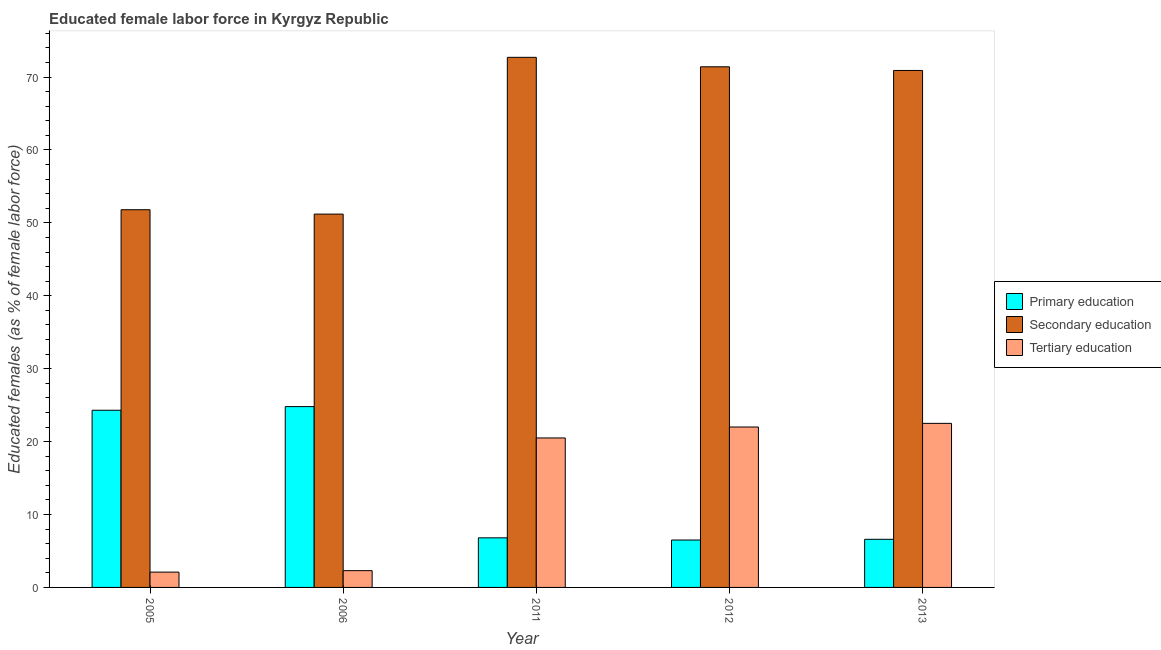What is the percentage of female labor force who received tertiary education in 2006?
Offer a terse response. 2.3. Across all years, what is the maximum percentage of female labor force who received tertiary education?
Give a very brief answer. 22.5. Across all years, what is the minimum percentage of female labor force who received tertiary education?
Offer a terse response. 2.1. In which year was the percentage of female labor force who received tertiary education maximum?
Make the answer very short. 2013. What is the total percentage of female labor force who received tertiary education in the graph?
Your answer should be compact. 69.4. What is the difference between the percentage of female labor force who received tertiary education in 2006 and that in 2012?
Provide a short and direct response. -19.7. What is the difference between the percentage of female labor force who received tertiary education in 2013 and the percentage of female labor force who received primary education in 2005?
Make the answer very short. 20.4. What is the average percentage of female labor force who received primary education per year?
Your response must be concise. 13.8. In the year 2011, what is the difference between the percentage of female labor force who received primary education and percentage of female labor force who received tertiary education?
Your answer should be very brief. 0. What is the ratio of the percentage of female labor force who received secondary education in 2005 to that in 2006?
Provide a short and direct response. 1.01. What is the difference between the highest and the second highest percentage of female labor force who received secondary education?
Offer a very short reply. 1.3. What is the difference between the highest and the lowest percentage of female labor force who received primary education?
Provide a short and direct response. 18.3. What does the 2nd bar from the left in 2013 represents?
Your answer should be very brief. Secondary education. What does the 1st bar from the right in 2013 represents?
Provide a short and direct response. Tertiary education. Are all the bars in the graph horizontal?
Keep it short and to the point. No. What is the difference between two consecutive major ticks on the Y-axis?
Make the answer very short. 10. Are the values on the major ticks of Y-axis written in scientific E-notation?
Provide a succinct answer. No. How many legend labels are there?
Make the answer very short. 3. How are the legend labels stacked?
Make the answer very short. Vertical. What is the title of the graph?
Offer a very short reply. Educated female labor force in Kyrgyz Republic. Does "Industrial Nitrous Oxide" appear as one of the legend labels in the graph?
Ensure brevity in your answer.  No. What is the label or title of the X-axis?
Offer a very short reply. Year. What is the label or title of the Y-axis?
Ensure brevity in your answer.  Educated females (as % of female labor force). What is the Educated females (as % of female labor force) in Primary education in 2005?
Your answer should be compact. 24.3. What is the Educated females (as % of female labor force) in Secondary education in 2005?
Keep it short and to the point. 51.8. What is the Educated females (as % of female labor force) in Tertiary education in 2005?
Offer a very short reply. 2.1. What is the Educated females (as % of female labor force) in Primary education in 2006?
Keep it short and to the point. 24.8. What is the Educated females (as % of female labor force) in Secondary education in 2006?
Provide a short and direct response. 51.2. What is the Educated females (as % of female labor force) in Tertiary education in 2006?
Your response must be concise. 2.3. What is the Educated females (as % of female labor force) of Primary education in 2011?
Keep it short and to the point. 6.8. What is the Educated females (as % of female labor force) of Secondary education in 2011?
Provide a short and direct response. 72.7. What is the Educated females (as % of female labor force) of Tertiary education in 2011?
Offer a terse response. 20.5. What is the Educated females (as % of female labor force) in Primary education in 2012?
Make the answer very short. 6.5. What is the Educated females (as % of female labor force) of Secondary education in 2012?
Your answer should be very brief. 71.4. What is the Educated females (as % of female labor force) of Tertiary education in 2012?
Keep it short and to the point. 22. What is the Educated females (as % of female labor force) of Primary education in 2013?
Provide a short and direct response. 6.6. What is the Educated females (as % of female labor force) in Secondary education in 2013?
Ensure brevity in your answer.  70.9. What is the Educated females (as % of female labor force) in Tertiary education in 2013?
Your response must be concise. 22.5. Across all years, what is the maximum Educated females (as % of female labor force) in Primary education?
Your answer should be very brief. 24.8. Across all years, what is the maximum Educated females (as % of female labor force) of Secondary education?
Your answer should be compact. 72.7. Across all years, what is the maximum Educated females (as % of female labor force) of Tertiary education?
Your answer should be compact. 22.5. Across all years, what is the minimum Educated females (as % of female labor force) in Primary education?
Provide a succinct answer. 6.5. Across all years, what is the minimum Educated females (as % of female labor force) of Secondary education?
Offer a very short reply. 51.2. Across all years, what is the minimum Educated females (as % of female labor force) of Tertiary education?
Your response must be concise. 2.1. What is the total Educated females (as % of female labor force) of Secondary education in the graph?
Keep it short and to the point. 318. What is the total Educated females (as % of female labor force) in Tertiary education in the graph?
Ensure brevity in your answer.  69.4. What is the difference between the Educated females (as % of female labor force) in Secondary education in 2005 and that in 2006?
Your response must be concise. 0.6. What is the difference between the Educated females (as % of female labor force) of Tertiary education in 2005 and that in 2006?
Keep it short and to the point. -0.2. What is the difference between the Educated females (as % of female labor force) in Secondary education in 2005 and that in 2011?
Your answer should be compact. -20.9. What is the difference between the Educated females (as % of female labor force) in Tertiary education in 2005 and that in 2011?
Offer a very short reply. -18.4. What is the difference between the Educated females (as % of female labor force) in Secondary education in 2005 and that in 2012?
Your response must be concise. -19.6. What is the difference between the Educated females (as % of female labor force) in Tertiary education in 2005 and that in 2012?
Offer a very short reply. -19.9. What is the difference between the Educated females (as % of female labor force) in Primary education in 2005 and that in 2013?
Ensure brevity in your answer.  17.7. What is the difference between the Educated females (as % of female labor force) of Secondary education in 2005 and that in 2013?
Make the answer very short. -19.1. What is the difference between the Educated females (as % of female labor force) in Tertiary education in 2005 and that in 2013?
Offer a very short reply. -20.4. What is the difference between the Educated females (as % of female labor force) in Secondary education in 2006 and that in 2011?
Make the answer very short. -21.5. What is the difference between the Educated females (as % of female labor force) of Tertiary education in 2006 and that in 2011?
Ensure brevity in your answer.  -18.2. What is the difference between the Educated females (as % of female labor force) of Primary education in 2006 and that in 2012?
Make the answer very short. 18.3. What is the difference between the Educated females (as % of female labor force) of Secondary education in 2006 and that in 2012?
Your response must be concise. -20.2. What is the difference between the Educated females (as % of female labor force) in Tertiary education in 2006 and that in 2012?
Provide a succinct answer. -19.7. What is the difference between the Educated females (as % of female labor force) in Primary education in 2006 and that in 2013?
Your response must be concise. 18.2. What is the difference between the Educated females (as % of female labor force) of Secondary education in 2006 and that in 2013?
Provide a succinct answer. -19.7. What is the difference between the Educated females (as % of female labor force) in Tertiary education in 2006 and that in 2013?
Your response must be concise. -20.2. What is the difference between the Educated females (as % of female labor force) in Secondary education in 2011 and that in 2012?
Keep it short and to the point. 1.3. What is the difference between the Educated females (as % of female labor force) in Primary education in 2011 and that in 2013?
Provide a short and direct response. 0.2. What is the difference between the Educated females (as % of female labor force) of Primary education in 2005 and the Educated females (as % of female labor force) of Secondary education in 2006?
Ensure brevity in your answer.  -26.9. What is the difference between the Educated females (as % of female labor force) of Primary education in 2005 and the Educated females (as % of female labor force) of Tertiary education in 2006?
Offer a terse response. 22. What is the difference between the Educated females (as % of female labor force) in Secondary education in 2005 and the Educated females (as % of female labor force) in Tertiary education in 2006?
Give a very brief answer. 49.5. What is the difference between the Educated females (as % of female labor force) in Primary education in 2005 and the Educated females (as % of female labor force) in Secondary education in 2011?
Make the answer very short. -48.4. What is the difference between the Educated females (as % of female labor force) in Primary education in 2005 and the Educated females (as % of female labor force) in Tertiary education in 2011?
Provide a short and direct response. 3.8. What is the difference between the Educated females (as % of female labor force) of Secondary education in 2005 and the Educated females (as % of female labor force) of Tertiary education in 2011?
Ensure brevity in your answer.  31.3. What is the difference between the Educated females (as % of female labor force) in Primary education in 2005 and the Educated females (as % of female labor force) in Secondary education in 2012?
Keep it short and to the point. -47.1. What is the difference between the Educated females (as % of female labor force) in Primary education in 2005 and the Educated females (as % of female labor force) in Tertiary education in 2012?
Give a very brief answer. 2.3. What is the difference between the Educated females (as % of female labor force) in Secondary education in 2005 and the Educated females (as % of female labor force) in Tertiary education in 2012?
Provide a short and direct response. 29.8. What is the difference between the Educated females (as % of female labor force) in Primary education in 2005 and the Educated females (as % of female labor force) in Secondary education in 2013?
Provide a short and direct response. -46.6. What is the difference between the Educated females (as % of female labor force) of Secondary education in 2005 and the Educated females (as % of female labor force) of Tertiary education in 2013?
Give a very brief answer. 29.3. What is the difference between the Educated females (as % of female labor force) in Primary education in 2006 and the Educated females (as % of female labor force) in Secondary education in 2011?
Keep it short and to the point. -47.9. What is the difference between the Educated females (as % of female labor force) of Secondary education in 2006 and the Educated females (as % of female labor force) of Tertiary education in 2011?
Your answer should be very brief. 30.7. What is the difference between the Educated females (as % of female labor force) of Primary education in 2006 and the Educated females (as % of female labor force) of Secondary education in 2012?
Your answer should be very brief. -46.6. What is the difference between the Educated females (as % of female labor force) in Secondary education in 2006 and the Educated females (as % of female labor force) in Tertiary education in 2012?
Give a very brief answer. 29.2. What is the difference between the Educated females (as % of female labor force) in Primary education in 2006 and the Educated females (as % of female labor force) in Secondary education in 2013?
Offer a very short reply. -46.1. What is the difference between the Educated females (as % of female labor force) of Primary education in 2006 and the Educated females (as % of female labor force) of Tertiary education in 2013?
Provide a short and direct response. 2.3. What is the difference between the Educated females (as % of female labor force) in Secondary education in 2006 and the Educated females (as % of female labor force) in Tertiary education in 2013?
Your answer should be very brief. 28.7. What is the difference between the Educated females (as % of female labor force) of Primary education in 2011 and the Educated females (as % of female labor force) of Secondary education in 2012?
Offer a terse response. -64.6. What is the difference between the Educated females (as % of female labor force) of Primary education in 2011 and the Educated females (as % of female labor force) of Tertiary education in 2012?
Make the answer very short. -15.2. What is the difference between the Educated females (as % of female labor force) in Secondary education in 2011 and the Educated females (as % of female labor force) in Tertiary education in 2012?
Ensure brevity in your answer.  50.7. What is the difference between the Educated females (as % of female labor force) of Primary education in 2011 and the Educated females (as % of female labor force) of Secondary education in 2013?
Make the answer very short. -64.1. What is the difference between the Educated females (as % of female labor force) of Primary education in 2011 and the Educated females (as % of female labor force) of Tertiary education in 2013?
Make the answer very short. -15.7. What is the difference between the Educated females (as % of female labor force) of Secondary education in 2011 and the Educated females (as % of female labor force) of Tertiary education in 2013?
Your answer should be compact. 50.2. What is the difference between the Educated females (as % of female labor force) of Primary education in 2012 and the Educated females (as % of female labor force) of Secondary education in 2013?
Ensure brevity in your answer.  -64.4. What is the difference between the Educated females (as % of female labor force) in Secondary education in 2012 and the Educated females (as % of female labor force) in Tertiary education in 2013?
Offer a terse response. 48.9. What is the average Educated females (as % of female labor force) in Primary education per year?
Offer a terse response. 13.8. What is the average Educated females (as % of female labor force) in Secondary education per year?
Your answer should be compact. 63.6. What is the average Educated females (as % of female labor force) of Tertiary education per year?
Offer a very short reply. 13.88. In the year 2005, what is the difference between the Educated females (as % of female labor force) in Primary education and Educated females (as % of female labor force) in Secondary education?
Provide a succinct answer. -27.5. In the year 2005, what is the difference between the Educated females (as % of female labor force) of Primary education and Educated females (as % of female labor force) of Tertiary education?
Give a very brief answer. 22.2. In the year 2005, what is the difference between the Educated females (as % of female labor force) in Secondary education and Educated females (as % of female labor force) in Tertiary education?
Your answer should be very brief. 49.7. In the year 2006, what is the difference between the Educated females (as % of female labor force) of Primary education and Educated females (as % of female labor force) of Secondary education?
Make the answer very short. -26.4. In the year 2006, what is the difference between the Educated females (as % of female labor force) in Primary education and Educated females (as % of female labor force) in Tertiary education?
Offer a terse response. 22.5. In the year 2006, what is the difference between the Educated females (as % of female labor force) in Secondary education and Educated females (as % of female labor force) in Tertiary education?
Your answer should be compact. 48.9. In the year 2011, what is the difference between the Educated females (as % of female labor force) of Primary education and Educated females (as % of female labor force) of Secondary education?
Your answer should be compact. -65.9. In the year 2011, what is the difference between the Educated females (as % of female labor force) in Primary education and Educated females (as % of female labor force) in Tertiary education?
Provide a short and direct response. -13.7. In the year 2011, what is the difference between the Educated females (as % of female labor force) of Secondary education and Educated females (as % of female labor force) of Tertiary education?
Give a very brief answer. 52.2. In the year 2012, what is the difference between the Educated females (as % of female labor force) in Primary education and Educated females (as % of female labor force) in Secondary education?
Offer a very short reply. -64.9. In the year 2012, what is the difference between the Educated females (as % of female labor force) of Primary education and Educated females (as % of female labor force) of Tertiary education?
Make the answer very short. -15.5. In the year 2012, what is the difference between the Educated females (as % of female labor force) of Secondary education and Educated females (as % of female labor force) of Tertiary education?
Your response must be concise. 49.4. In the year 2013, what is the difference between the Educated females (as % of female labor force) of Primary education and Educated females (as % of female labor force) of Secondary education?
Provide a short and direct response. -64.3. In the year 2013, what is the difference between the Educated females (as % of female labor force) of Primary education and Educated females (as % of female labor force) of Tertiary education?
Your answer should be very brief. -15.9. In the year 2013, what is the difference between the Educated females (as % of female labor force) of Secondary education and Educated females (as % of female labor force) of Tertiary education?
Offer a very short reply. 48.4. What is the ratio of the Educated females (as % of female labor force) in Primary education in 2005 to that in 2006?
Your answer should be compact. 0.98. What is the ratio of the Educated females (as % of female labor force) of Secondary education in 2005 to that in 2006?
Make the answer very short. 1.01. What is the ratio of the Educated females (as % of female labor force) in Primary education in 2005 to that in 2011?
Offer a terse response. 3.57. What is the ratio of the Educated females (as % of female labor force) of Secondary education in 2005 to that in 2011?
Your response must be concise. 0.71. What is the ratio of the Educated females (as % of female labor force) in Tertiary education in 2005 to that in 2011?
Give a very brief answer. 0.1. What is the ratio of the Educated females (as % of female labor force) in Primary education in 2005 to that in 2012?
Give a very brief answer. 3.74. What is the ratio of the Educated females (as % of female labor force) of Secondary education in 2005 to that in 2012?
Provide a short and direct response. 0.73. What is the ratio of the Educated females (as % of female labor force) in Tertiary education in 2005 to that in 2012?
Your response must be concise. 0.1. What is the ratio of the Educated females (as % of female labor force) of Primary education in 2005 to that in 2013?
Ensure brevity in your answer.  3.68. What is the ratio of the Educated females (as % of female labor force) of Secondary education in 2005 to that in 2013?
Provide a succinct answer. 0.73. What is the ratio of the Educated females (as % of female labor force) in Tertiary education in 2005 to that in 2013?
Offer a terse response. 0.09. What is the ratio of the Educated females (as % of female labor force) in Primary education in 2006 to that in 2011?
Offer a very short reply. 3.65. What is the ratio of the Educated females (as % of female labor force) in Secondary education in 2006 to that in 2011?
Offer a very short reply. 0.7. What is the ratio of the Educated females (as % of female labor force) in Tertiary education in 2006 to that in 2011?
Give a very brief answer. 0.11. What is the ratio of the Educated females (as % of female labor force) of Primary education in 2006 to that in 2012?
Your answer should be compact. 3.82. What is the ratio of the Educated females (as % of female labor force) in Secondary education in 2006 to that in 2012?
Provide a short and direct response. 0.72. What is the ratio of the Educated females (as % of female labor force) in Tertiary education in 2006 to that in 2012?
Offer a very short reply. 0.1. What is the ratio of the Educated females (as % of female labor force) in Primary education in 2006 to that in 2013?
Provide a short and direct response. 3.76. What is the ratio of the Educated females (as % of female labor force) in Secondary education in 2006 to that in 2013?
Your answer should be compact. 0.72. What is the ratio of the Educated females (as % of female labor force) of Tertiary education in 2006 to that in 2013?
Your answer should be compact. 0.1. What is the ratio of the Educated females (as % of female labor force) in Primary education in 2011 to that in 2012?
Your answer should be very brief. 1.05. What is the ratio of the Educated females (as % of female labor force) in Secondary education in 2011 to that in 2012?
Offer a terse response. 1.02. What is the ratio of the Educated females (as % of female labor force) of Tertiary education in 2011 to that in 2012?
Offer a very short reply. 0.93. What is the ratio of the Educated females (as % of female labor force) of Primary education in 2011 to that in 2013?
Your response must be concise. 1.03. What is the ratio of the Educated females (as % of female labor force) in Secondary education in 2011 to that in 2013?
Your answer should be very brief. 1.03. What is the ratio of the Educated females (as % of female labor force) of Tertiary education in 2011 to that in 2013?
Offer a terse response. 0.91. What is the ratio of the Educated females (as % of female labor force) of Primary education in 2012 to that in 2013?
Make the answer very short. 0.98. What is the ratio of the Educated females (as % of female labor force) of Secondary education in 2012 to that in 2013?
Your answer should be compact. 1.01. What is the ratio of the Educated females (as % of female labor force) of Tertiary education in 2012 to that in 2013?
Make the answer very short. 0.98. What is the difference between the highest and the second highest Educated females (as % of female labor force) in Primary education?
Make the answer very short. 0.5. What is the difference between the highest and the second highest Educated females (as % of female labor force) in Secondary education?
Your response must be concise. 1.3. What is the difference between the highest and the lowest Educated females (as % of female labor force) in Primary education?
Offer a very short reply. 18.3. What is the difference between the highest and the lowest Educated females (as % of female labor force) in Tertiary education?
Your answer should be compact. 20.4. 